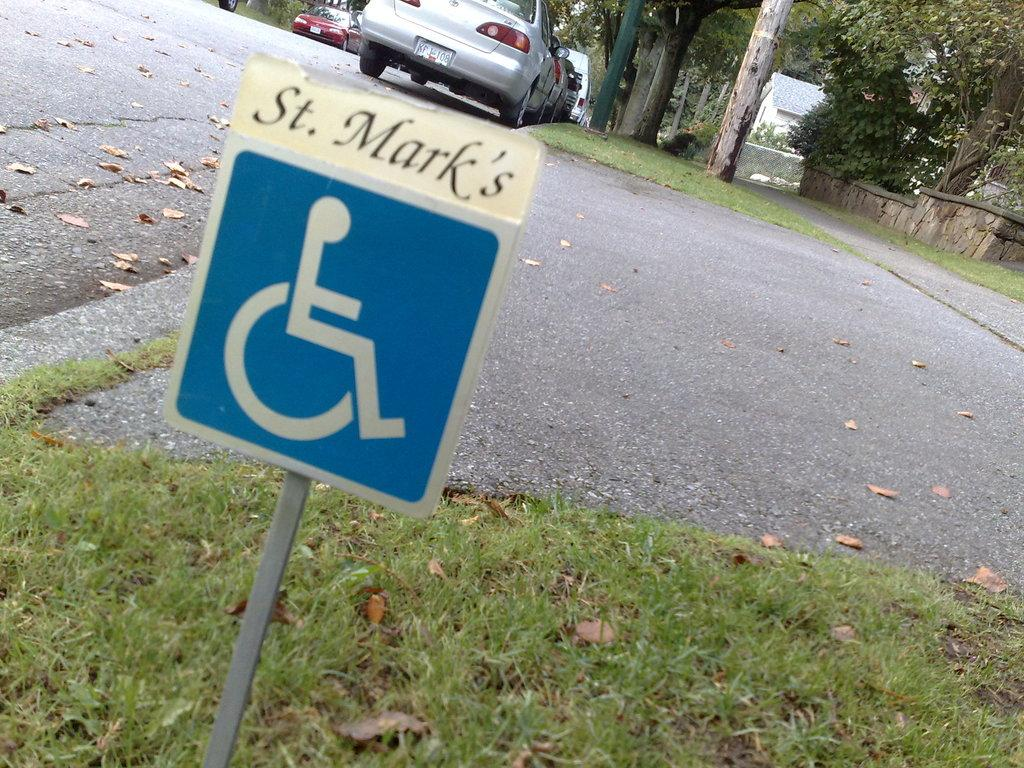What type of surface can be seen in the image? There is a road in the image. What covers the ground in the image? The ground is covered with grass. What can be found on the ground in the image? There are objects on the ground. What type of vegetation is present in the image? There are trees and plants in the image. What structure is visible in the image? There is a wall in the image. What type of buildings can be seen in the image? There are houses in the image. What type of transportation is present in the image? There are vehicles in the image. What type of information might be conveyed in the image? There is a signboard in the image. What type of vertical structure is present in the image? There is a pole in the image. What type of ship can be seen sailing in the image? There is no ship present in the image; it features a road, grass, objects, trees, plants, a wall, houses, vehicles, and a signboard. What color is the behavior of the objects on the ground in the image? The question is unclear and does not relate to any aspect of the image. The image does not depict the behavior of objects, nor does it involve colors in that context. 